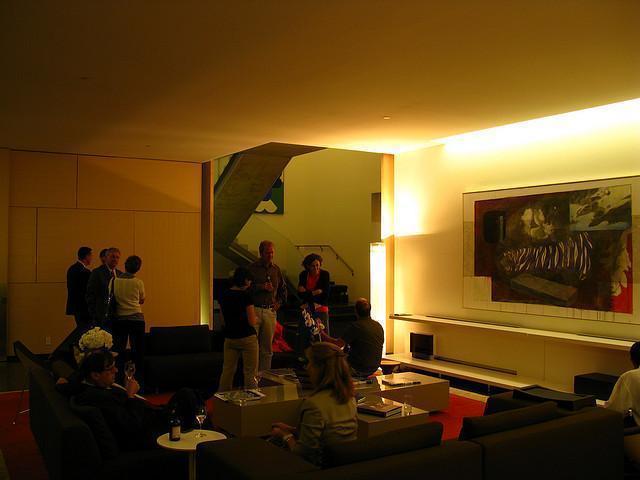What is the design of the staircase called?
Indicate the correct choice and explain in the format: 'Answer: answer
Rationale: rationale.'
Options: Tall staircase, l-shaped staircase, turning staircase, curved staircase. Answer: l-shaped staircase.
Rationale: This is a l shaped staircase because of how it turns at the bottom. 